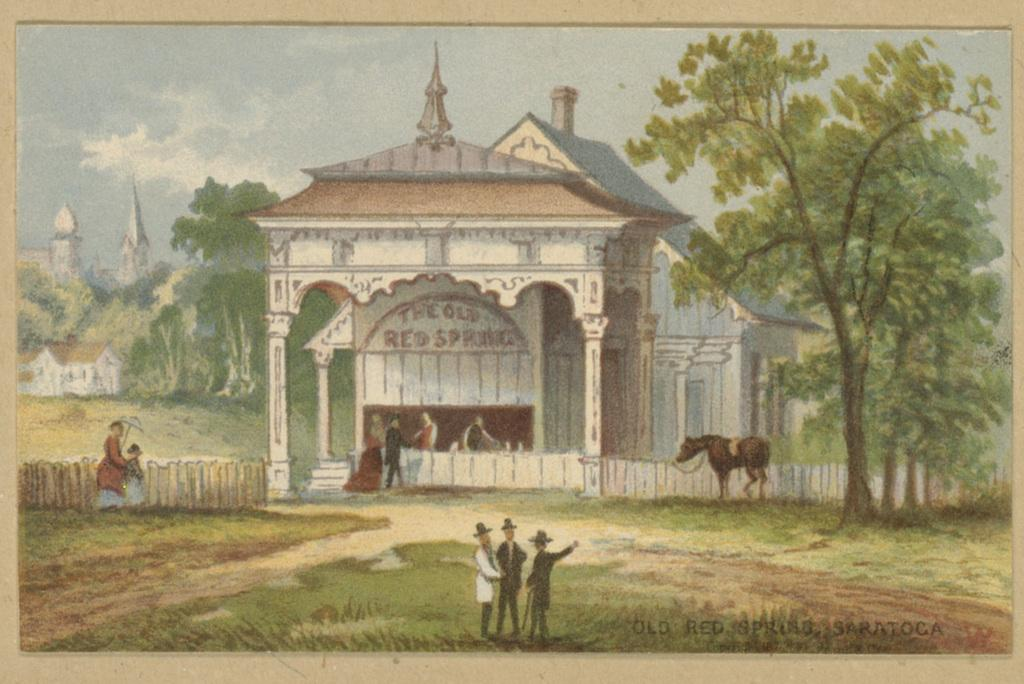What is the main subject of the painting in the image? The painting depicts the sky, clouds, trees, buildings, and grass. Can you describe the elements of nature depicted in the painting? The painting depicts clouds, trees, and grass. Are there any man-made structures depicted in the painting? Yes, the painting depicts buildings. Is there any text present in the painting? Yes, the painting contains some text. Are there any living creatures depicted in the painting? Yes, the painting includes an animal. How many hands are visible in the painting? There are no hands visible in the painting; it depicts the sky, clouds, trees, buildings, grass, text, and an animal. Can you describe the cow depicted in the painting? There is no cow depicted in the painting; it includes an animal, but the specific type of animal is not mentioned in the provided facts. 